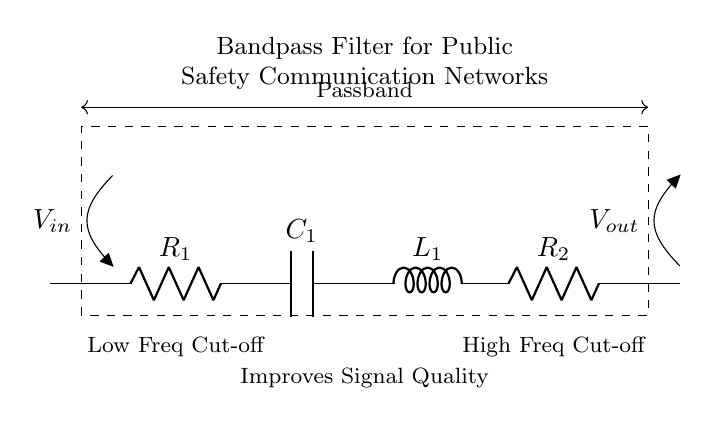What are the components used in the filter? The circuit diagram shows two resistors (R1 and R2), one capacitor (C1), and one inductor (L1).
Answer: Resistors, capacitor, inductor What is the purpose of the bandpass filter? The bandpass filter's main purpose is to enhance or improve signal quality by allowing a certain frequency range to pass while attenuating others.
Answer: To improve signal quality What is the low-frequency cut-off in this circuit? The low-frequency cut-off is associated with the component placements that determine the lower limit of the passband; in this diagram, it is indicated near R1 and C1.
Answer: R1 and C1 What is the high-frequency cut-off in this circuit? The high-frequency cut-off is determined by the arrangement of the components, specifically R2 and L1, which set the upper limit of the passband.
Answer: R2 and L1 Why is a bandpass filter important for public safety communication networks? A bandpass filter is crucial as it reduces noise and interference, allowing only the necessary communication signals to pass, enhancing clarity and reliability for safety operations.
Answer: To reduce noise/interference Which components form the passband in this circuit? The components forming the passband are comprised of R2, C1, and L1, working together to allow a specific range of frequencies to pass between the low and high cut-offs.
Answer: R2, C1, L1 